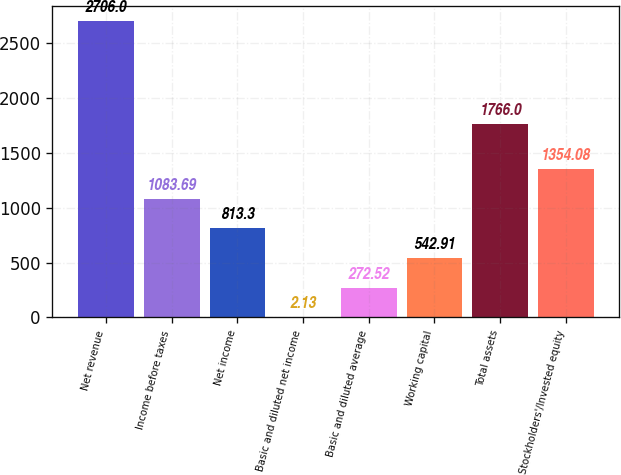<chart> <loc_0><loc_0><loc_500><loc_500><bar_chart><fcel>Net revenue<fcel>Income before taxes<fcel>Net income<fcel>Basic and diluted net income<fcel>Basic and diluted average<fcel>Working capital<fcel>Total assets<fcel>Stockholders'/Invested equity<nl><fcel>2706<fcel>1083.69<fcel>813.3<fcel>2.13<fcel>272.52<fcel>542.91<fcel>1766<fcel>1354.08<nl></chart> 